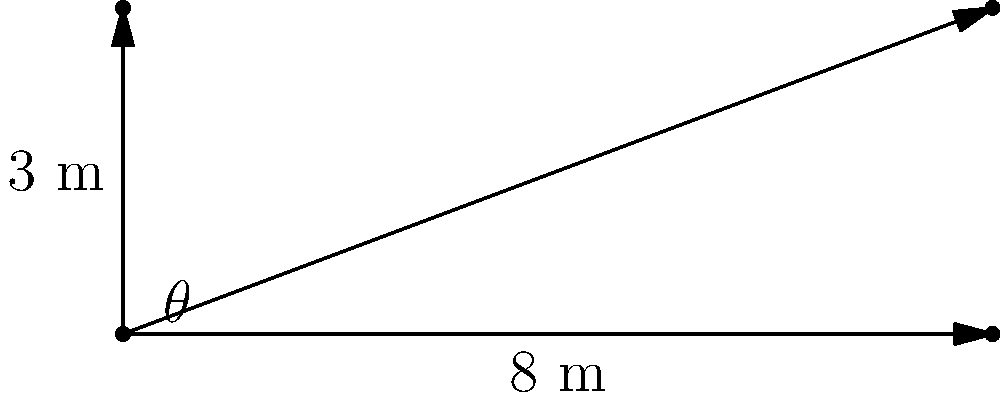As a logistics manager for a Mercedes transportation company, you need to determine the optimal angle for loading ramps to safely transport vehicles onto trucks. Given a truck bed height of 3 meters and a maximum safe ramp length of 8 meters, what is the optimal angle $\theta$ (in degrees) for the loading ramp? To solve this problem, we'll use basic trigonometry:

1. We have a right triangle with:
   - Adjacent side (horizontal distance) = 8 meters
   - Opposite side (vertical height) = 3 meters
   - Hypotenuse (ramp length) = 8 meters (maximum safe length)

2. To find the angle $\theta$, we'll use the tangent function:

   $$\tan(\theta) = \frac{\text{opposite}}{\text{adjacent}} = \frac{3}{8}$$

3. To solve for $\theta$, we take the inverse tangent (arctangent):

   $$\theta = \tan^{-1}\left(\frac{3}{8}\right)$$

4. Using a calculator or trigonometric tables:

   $$\theta \approx 20.556^\circ$$

5. Rounding to the nearest degree:

   $$\theta \approx 21^\circ$$

This angle provides the optimal balance between the ramp length and the truck bed height, ensuring safe loading of Mercedes vehicles.
Answer: $21^\circ$ 